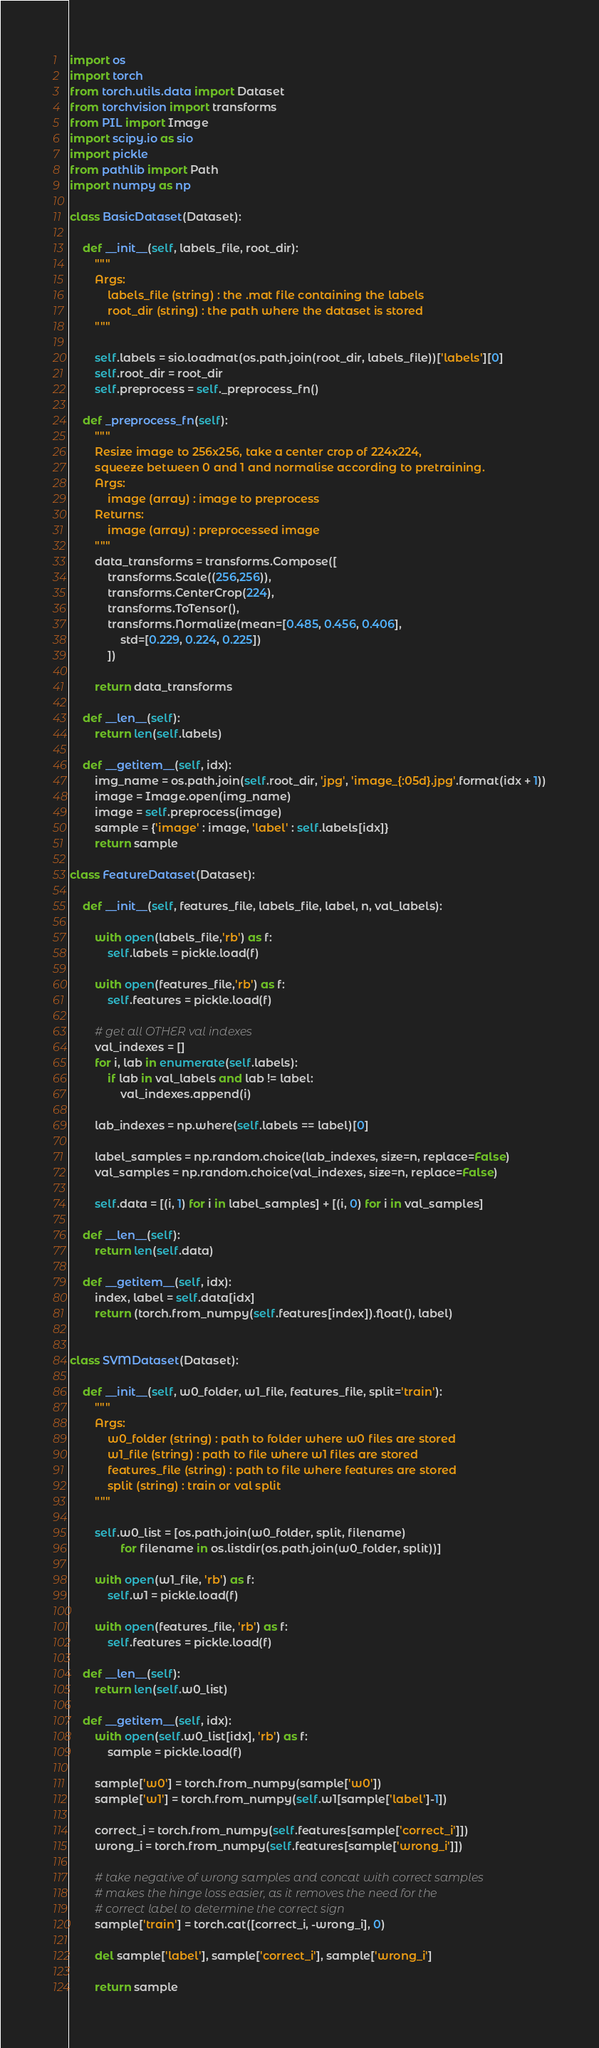<code> <loc_0><loc_0><loc_500><loc_500><_Python_>import os
import torch
from torch.utils.data import Dataset
from torchvision import transforms
from PIL import Image
import scipy.io as sio
import pickle
from pathlib import Path
import numpy as np

class BasicDataset(Dataset):

    def __init__(self, labels_file, root_dir):
        """
        Args:
            labels_file (string) : the .mat file containing the labels
            root_dir (string) : the path where the dataset is stored
        """

        self.labels = sio.loadmat(os.path.join(root_dir, labels_file))['labels'][0]
        self.root_dir = root_dir
        self.preprocess = self._preprocess_fn()

    def _preprocess_fn(self):
        """
        Resize image to 256x256, take a center crop of 224x224,
        squeeze between 0 and 1 and normalise according to pretraining.
        Args:
            image (array) : image to preprocess
        Returns:
            image (array) : preprocessed image
        """
        data_transforms = transforms.Compose([
            transforms.Scale((256,256)),
            transforms.CenterCrop(224),
            transforms.ToTensor(),
            transforms.Normalize(mean=[0.485, 0.456, 0.406],
                std=[0.229, 0.224, 0.225])
            ])

        return data_transforms

    def __len__(self):
        return len(self.labels)

    def __getitem__(self, idx):
        img_name = os.path.join(self.root_dir, 'jpg', 'image_{:05d}.jpg'.format(idx + 1))
        image = Image.open(img_name)
        image = self.preprocess(image)
        sample = {'image' : image, 'label' : self.labels[idx]}
        return sample

class FeatureDataset(Dataset):

    def __init__(self, features_file, labels_file, label, n, val_labels):

        with open(labels_file,'rb') as f:
            self.labels = pickle.load(f)

        with open(features_file,'rb') as f:
            self.features = pickle.load(f)
        
        # get all OTHER val indexes
        val_indexes = []
        for i, lab in enumerate(self.labels):
            if lab in val_labels and lab != label:
                val_indexes.append(i)

        lab_indexes = np.where(self.labels == label)[0]

        label_samples = np.random.choice(lab_indexes, size=n, replace=False)
        val_samples = np.random.choice(val_indexes, size=n, replace=False)

        self.data = [(i, 1) for i in label_samples] + [(i, 0) for i in val_samples]

    def __len__(self):
        return len(self.data)

    def __getitem__(self, idx):
        index, label = self.data[idx]
        return (torch.from_numpy(self.features[index]).float(), label)


class SVMDataset(Dataset):

    def __init__(self, w0_folder, w1_file, features_file, split='train'):
        """
        Args:
            w0_folder (string) : path to folder where w0 files are stored
            w1_file (string) : path to file where w1 files are stored
            features_file (string) : path to file where features are stored
            split (string) : train or val split
        """

        self.w0_list = [os.path.join(w0_folder, split, filename) 
                for filename in os.listdir(os.path.join(w0_folder, split))]

        with open(w1_file, 'rb') as f:
            self.w1 = pickle.load(f)

        with open(features_file, 'rb') as f:
            self.features = pickle.load(f)

    def __len__(self):
        return len(self.w0_list)

    def __getitem__(self, idx):
        with open(self.w0_list[idx], 'rb') as f:
            sample = pickle.load(f)

        sample['w0'] = torch.from_numpy(sample['w0'])
        sample['w1'] = torch.from_numpy(self.w1[sample['label']-1])

        correct_i = torch.from_numpy(self.features[sample['correct_i']])
        wrong_i = torch.from_numpy(self.features[sample['wrong_i']])

        # take negative of wrong samples and concat with correct samples
        # makes the hinge loss easier, as it removes the need for the
        # correct label to determine the correct sign
        sample['train'] = torch.cat([correct_i, -wrong_i], 0)

        del sample['label'], sample['correct_i'], sample['wrong_i']

        return sample
</code> 